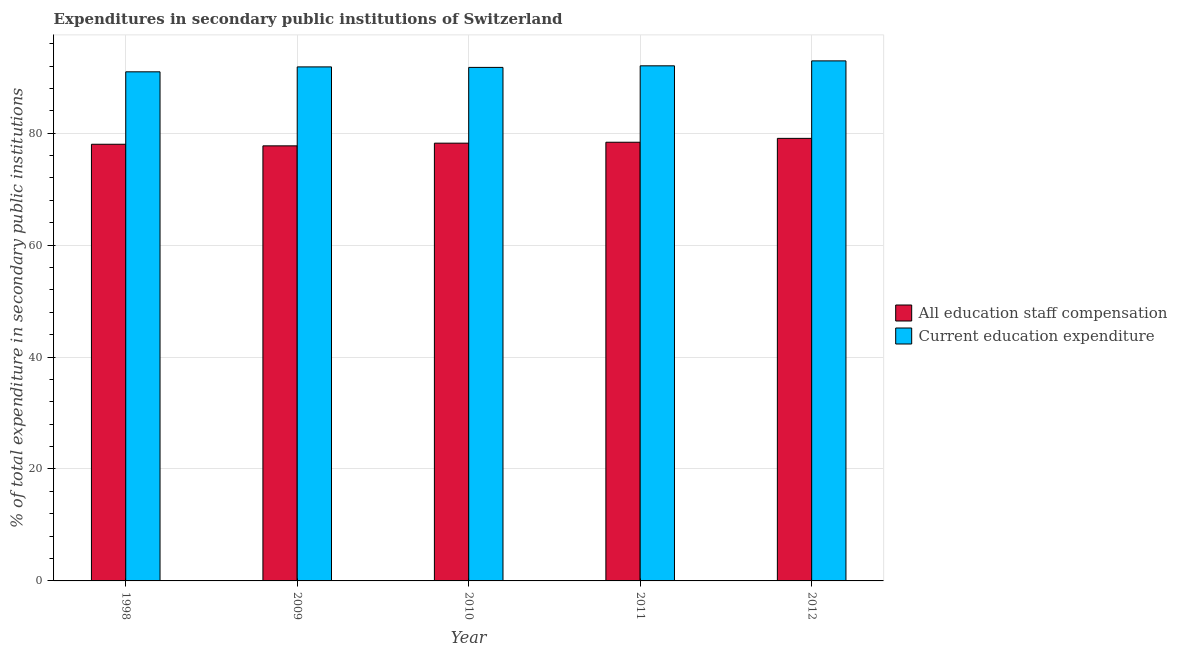How many groups of bars are there?
Offer a terse response. 5. Are the number of bars per tick equal to the number of legend labels?
Give a very brief answer. Yes. How many bars are there on the 2nd tick from the left?
Your answer should be compact. 2. How many bars are there on the 5th tick from the right?
Give a very brief answer. 2. What is the label of the 5th group of bars from the left?
Offer a terse response. 2012. What is the expenditure in education in 2010?
Your answer should be compact. 91.76. Across all years, what is the maximum expenditure in education?
Give a very brief answer. 92.92. Across all years, what is the minimum expenditure in education?
Make the answer very short. 90.96. In which year was the expenditure in education maximum?
Offer a terse response. 2012. In which year was the expenditure in education minimum?
Your answer should be very brief. 1998. What is the total expenditure in staff compensation in the graph?
Make the answer very short. 391.44. What is the difference between the expenditure in staff compensation in 2011 and that in 2012?
Your answer should be very brief. -0.69. What is the difference between the expenditure in education in 2010 and the expenditure in staff compensation in 2009?
Your answer should be compact. -0.09. What is the average expenditure in staff compensation per year?
Make the answer very short. 78.29. What is the ratio of the expenditure in education in 2009 to that in 2010?
Offer a terse response. 1. Is the difference between the expenditure in education in 1998 and 2011 greater than the difference between the expenditure in staff compensation in 1998 and 2011?
Your answer should be compact. No. What is the difference between the highest and the second highest expenditure in education?
Your answer should be very brief. 0.88. What is the difference between the highest and the lowest expenditure in staff compensation?
Make the answer very short. 1.34. In how many years, is the expenditure in education greater than the average expenditure in education taken over all years?
Keep it short and to the point. 2. Is the sum of the expenditure in staff compensation in 2011 and 2012 greater than the maximum expenditure in education across all years?
Make the answer very short. Yes. What does the 1st bar from the left in 2012 represents?
Your response must be concise. All education staff compensation. What does the 2nd bar from the right in 2012 represents?
Provide a succinct answer. All education staff compensation. How many bars are there?
Provide a succinct answer. 10. Are all the bars in the graph horizontal?
Provide a short and direct response. No. Are the values on the major ticks of Y-axis written in scientific E-notation?
Give a very brief answer. No. Does the graph contain grids?
Ensure brevity in your answer.  Yes. What is the title of the graph?
Your response must be concise. Expenditures in secondary public institutions of Switzerland. What is the label or title of the X-axis?
Keep it short and to the point. Year. What is the label or title of the Y-axis?
Your response must be concise. % of total expenditure in secondary public institutions. What is the % of total expenditure in secondary public institutions of All education staff compensation in 1998?
Offer a very short reply. 78.02. What is the % of total expenditure in secondary public institutions in Current education expenditure in 1998?
Your answer should be compact. 90.96. What is the % of total expenditure in secondary public institutions in All education staff compensation in 2009?
Give a very brief answer. 77.74. What is the % of total expenditure in secondary public institutions of Current education expenditure in 2009?
Your response must be concise. 91.84. What is the % of total expenditure in secondary public institutions of All education staff compensation in 2010?
Make the answer very short. 78.22. What is the % of total expenditure in secondary public institutions in Current education expenditure in 2010?
Your response must be concise. 91.76. What is the % of total expenditure in secondary public institutions of All education staff compensation in 2011?
Ensure brevity in your answer.  78.38. What is the % of total expenditure in secondary public institutions of Current education expenditure in 2011?
Ensure brevity in your answer.  92.04. What is the % of total expenditure in secondary public institutions of All education staff compensation in 2012?
Ensure brevity in your answer.  79.07. What is the % of total expenditure in secondary public institutions of Current education expenditure in 2012?
Ensure brevity in your answer.  92.92. Across all years, what is the maximum % of total expenditure in secondary public institutions in All education staff compensation?
Provide a short and direct response. 79.07. Across all years, what is the maximum % of total expenditure in secondary public institutions in Current education expenditure?
Ensure brevity in your answer.  92.92. Across all years, what is the minimum % of total expenditure in secondary public institutions of All education staff compensation?
Ensure brevity in your answer.  77.74. Across all years, what is the minimum % of total expenditure in secondary public institutions in Current education expenditure?
Provide a succinct answer. 90.96. What is the total % of total expenditure in secondary public institutions of All education staff compensation in the graph?
Provide a short and direct response. 391.44. What is the total % of total expenditure in secondary public institutions of Current education expenditure in the graph?
Offer a very short reply. 459.52. What is the difference between the % of total expenditure in secondary public institutions of All education staff compensation in 1998 and that in 2009?
Provide a short and direct response. 0.29. What is the difference between the % of total expenditure in secondary public institutions in Current education expenditure in 1998 and that in 2009?
Keep it short and to the point. -0.88. What is the difference between the % of total expenditure in secondary public institutions in All education staff compensation in 1998 and that in 2010?
Offer a very short reply. -0.19. What is the difference between the % of total expenditure in secondary public institutions of Current education expenditure in 1998 and that in 2010?
Provide a succinct answer. -0.79. What is the difference between the % of total expenditure in secondary public institutions in All education staff compensation in 1998 and that in 2011?
Give a very brief answer. -0.36. What is the difference between the % of total expenditure in secondary public institutions in Current education expenditure in 1998 and that in 2011?
Your response must be concise. -1.07. What is the difference between the % of total expenditure in secondary public institutions of All education staff compensation in 1998 and that in 2012?
Your response must be concise. -1.05. What is the difference between the % of total expenditure in secondary public institutions of Current education expenditure in 1998 and that in 2012?
Make the answer very short. -1.96. What is the difference between the % of total expenditure in secondary public institutions in All education staff compensation in 2009 and that in 2010?
Your response must be concise. -0.48. What is the difference between the % of total expenditure in secondary public institutions in Current education expenditure in 2009 and that in 2010?
Your answer should be very brief. 0.09. What is the difference between the % of total expenditure in secondary public institutions of All education staff compensation in 2009 and that in 2011?
Make the answer very short. -0.64. What is the difference between the % of total expenditure in secondary public institutions of Current education expenditure in 2009 and that in 2011?
Your answer should be compact. -0.19. What is the difference between the % of total expenditure in secondary public institutions of All education staff compensation in 2009 and that in 2012?
Offer a terse response. -1.34. What is the difference between the % of total expenditure in secondary public institutions in Current education expenditure in 2009 and that in 2012?
Ensure brevity in your answer.  -1.08. What is the difference between the % of total expenditure in secondary public institutions of All education staff compensation in 2010 and that in 2011?
Keep it short and to the point. -0.16. What is the difference between the % of total expenditure in secondary public institutions of Current education expenditure in 2010 and that in 2011?
Offer a terse response. -0.28. What is the difference between the % of total expenditure in secondary public institutions of All education staff compensation in 2010 and that in 2012?
Give a very brief answer. -0.86. What is the difference between the % of total expenditure in secondary public institutions in Current education expenditure in 2010 and that in 2012?
Give a very brief answer. -1.16. What is the difference between the % of total expenditure in secondary public institutions of All education staff compensation in 2011 and that in 2012?
Make the answer very short. -0.69. What is the difference between the % of total expenditure in secondary public institutions of Current education expenditure in 2011 and that in 2012?
Provide a short and direct response. -0.88. What is the difference between the % of total expenditure in secondary public institutions in All education staff compensation in 1998 and the % of total expenditure in secondary public institutions in Current education expenditure in 2009?
Make the answer very short. -13.82. What is the difference between the % of total expenditure in secondary public institutions of All education staff compensation in 1998 and the % of total expenditure in secondary public institutions of Current education expenditure in 2010?
Your answer should be compact. -13.73. What is the difference between the % of total expenditure in secondary public institutions of All education staff compensation in 1998 and the % of total expenditure in secondary public institutions of Current education expenditure in 2011?
Offer a very short reply. -14.01. What is the difference between the % of total expenditure in secondary public institutions of All education staff compensation in 1998 and the % of total expenditure in secondary public institutions of Current education expenditure in 2012?
Ensure brevity in your answer.  -14.9. What is the difference between the % of total expenditure in secondary public institutions of All education staff compensation in 2009 and the % of total expenditure in secondary public institutions of Current education expenditure in 2010?
Keep it short and to the point. -14.02. What is the difference between the % of total expenditure in secondary public institutions in All education staff compensation in 2009 and the % of total expenditure in secondary public institutions in Current education expenditure in 2011?
Make the answer very short. -14.3. What is the difference between the % of total expenditure in secondary public institutions in All education staff compensation in 2009 and the % of total expenditure in secondary public institutions in Current education expenditure in 2012?
Offer a terse response. -15.18. What is the difference between the % of total expenditure in secondary public institutions in All education staff compensation in 2010 and the % of total expenditure in secondary public institutions in Current education expenditure in 2011?
Give a very brief answer. -13.82. What is the difference between the % of total expenditure in secondary public institutions of All education staff compensation in 2010 and the % of total expenditure in secondary public institutions of Current education expenditure in 2012?
Keep it short and to the point. -14.7. What is the difference between the % of total expenditure in secondary public institutions of All education staff compensation in 2011 and the % of total expenditure in secondary public institutions of Current education expenditure in 2012?
Your answer should be compact. -14.54. What is the average % of total expenditure in secondary public institutions of All education staff compensation per year?
Make the answer very short. 78.29. What is the average % of total expenditure in secondary public institutions of Current education expenditure per year?
Provide a succinct answer. 91.9. In the year 1998, what is the difference between the % of total expenditure in secondary public institutions in All education staff compensation and % of total expenditure in secondary public institutions in Current education expenditure?
Keep it short and to the point. -12.94. In the year 2009, what is the difference between the % of total expenditure in secondary public institutions in All education staff compensation and % of total expenditure in secondary public institutions in Current education expenditure?
Your answer should be very brief. -14.11. In the year 2010, what is the difference between the % of total expenditure in secondary public institutions in All education staff compensation and % of total expenditure in secondary public institutions in Current education expenditure?
Your answer should be very brief. -13.54. In the year 2011, what is the difference between the % of total expenditure in secondary public institutions of All education staff compensation and % of total expenditure in secondary public institutions of Current education expenditure?
Ensure brevity in your answer.  -13.65. In the year 2012, what is the difference between the % of total expenditure in secondary public institutions of All education staff compensation and % of total expenditure in secondary public institutions of Current education expenditure?
Keep it short and to the point. -13.85. What is the ratio of the % of total expenditure in secondary public institutions of All education staff compensation in 1998 to that in 2009?
Give a very brief answer. 1. What is the ratio of the % of total expenditure in secondary public institutions of All education staff compensation in 1998 to that in 2010?
Your answer should be compact. 1. What is the ratio of the % of total expenditure in secondary public institutions in Current education expenditure in 1998 to that in 2010?
Make the answer very short. 0.99. What is the ratio of the % of total expenditure in secondary public institutions of All education staff compensation in 1998 to that in 2011?
Ensure brevity in your answer.  1. What is the ratio of the % of total expenditure in secondary public institutions of Current education expenditure in 1998 to that in 2011?
Provide a succinct answer. 0.99. What is the ratio of the % of total expenditure in secondary public institutions in All education staff compensation in 1998 to that in 2012?
Your answer should be compact. 0.99. What is the ratio of the % of total expenditure in secondary public institutions of Current education expenditure in 1998 to that in 2012?
Your answer should be very brief. 0.98. What is the ratio of the % of total expenditure in secondary public institutions in All education staff compensation in 2009 to that in 2010?
Provide a succinct answer. 0.99. What is the ratio of the % of total expenditure in secondary public institutions of All education staff compensation in 2009 to that in 2012?
Provide a short and direct response. 0.98. What is the ratio of the % of total expenditure in secondary public institutions of Current education expenditure in 2009 to that in 2012?
Your answer should be compact. 0.99. What is the ratio of the % of total expenditure in secondary public institutions of Current education expenditure in 2010 to that in 2012?
Make the answer very short. 0.99. What is the ratio of the % of total expenditure in secondary public institutions in Current education expenditure in 2011 to that in 2012?
Provide a short and direct response. 0.99. What is the difference between the highest and the second highest % of total expenditure in secondary public institutions in All education staff compensation?
Your response must be concise. 0.69. What is the difference between the highest and the second highest % of total expenditure in secondary public institutions in Current education expenditure?
Ensure brevity in your answer.  0.88. What is the difference between the highest and the lowest % of total expenditure in secondary public institutions of All education staff compensation?
Provide a short and direct response. 1.34. What is the difference between the highest and the lowest % of total expenditure in secondary public institutions of Current education expenditure?
Give a very brief answer. 1.96. 